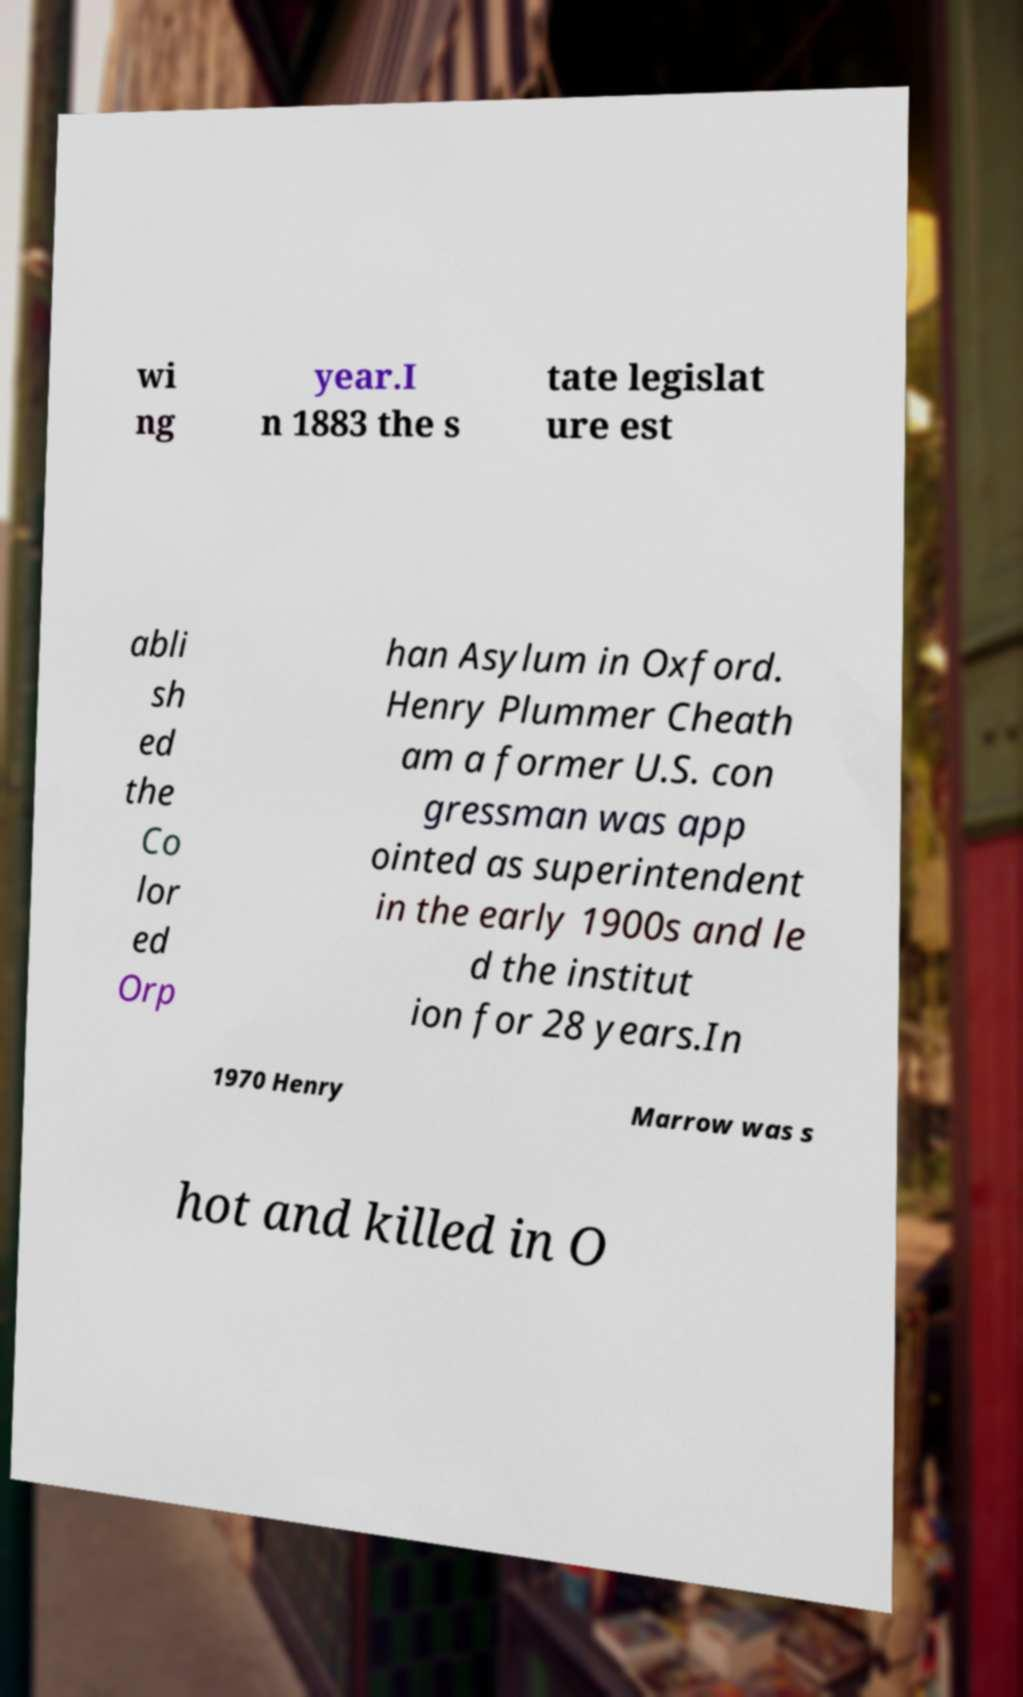Please read and relay the text visible in this image. What does it say? wi ng year.I n 1883 the s tate legislat ure est abli sh ed the Co lor ed Orp han Asylum in Oxford. Henry Plummer Cheath am a former U.S. con gressman was app ointed as superintendent in the early 1900s and le d the institut ion for 28 years.In 1970 Henry Marrow was s hot and killed in O 